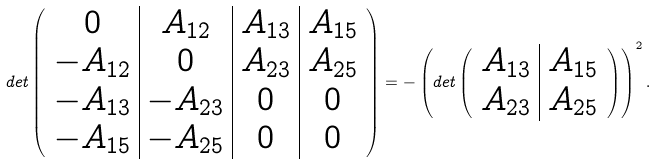Convert formula to latex. <formula><loc_0><loc_0><loc_500><loc_500>d e t \left ( \begin{array} { c | c | c | c } 0 & A _ { 1 2 } & A _ { 1 3 } & A _ { 1 5 } \\ - A _ { 1 2 } & 0 & A _ { 2 3 } & A _ { 2 5 } \\ - A _ { 1 3 } & - A _ { 2 3 } & 0 & 0 \\ - A _ { 1 5 } & - A _ { 2 5 } & 0 & 0 \end{array} \right ) = - \left ( d e t \left ( \begin{array} { c | c } A _ { 1 3 } & A _ { 1 5 } \\ A _ { 2 3 } & A _ { 2 5 } \end{array} \right ) \right ) ^ { 2 } .</formula> 